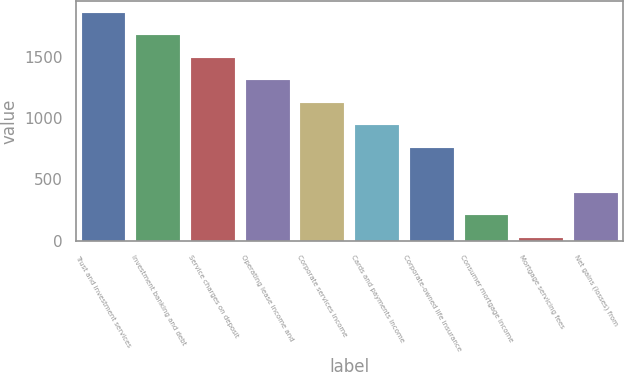Convert chart. <chart><loc_0><loc_0><loc_500><loc_500><bar_chart><fcel>Trust and investment services<fcel>Investment banking and debt<fcel>Service charges on deposit<fcel>Operating lease income and<fcel>Corporate services income<fcel>Cards and payments income<fcel>Corporate-owned life insurance<fcel>Consumer mortgage income<fcel>Mortgage servicing fees<fcel>Net gains (losses) from<nl><fcel>1856<fcel>1672.8<fcel>1489.6<fcel>1306.4<fcel>1123.2<fcel>940<fcel>756.8<fcel>207.2<fcel>24<fcel>390.4<nl></chart> 